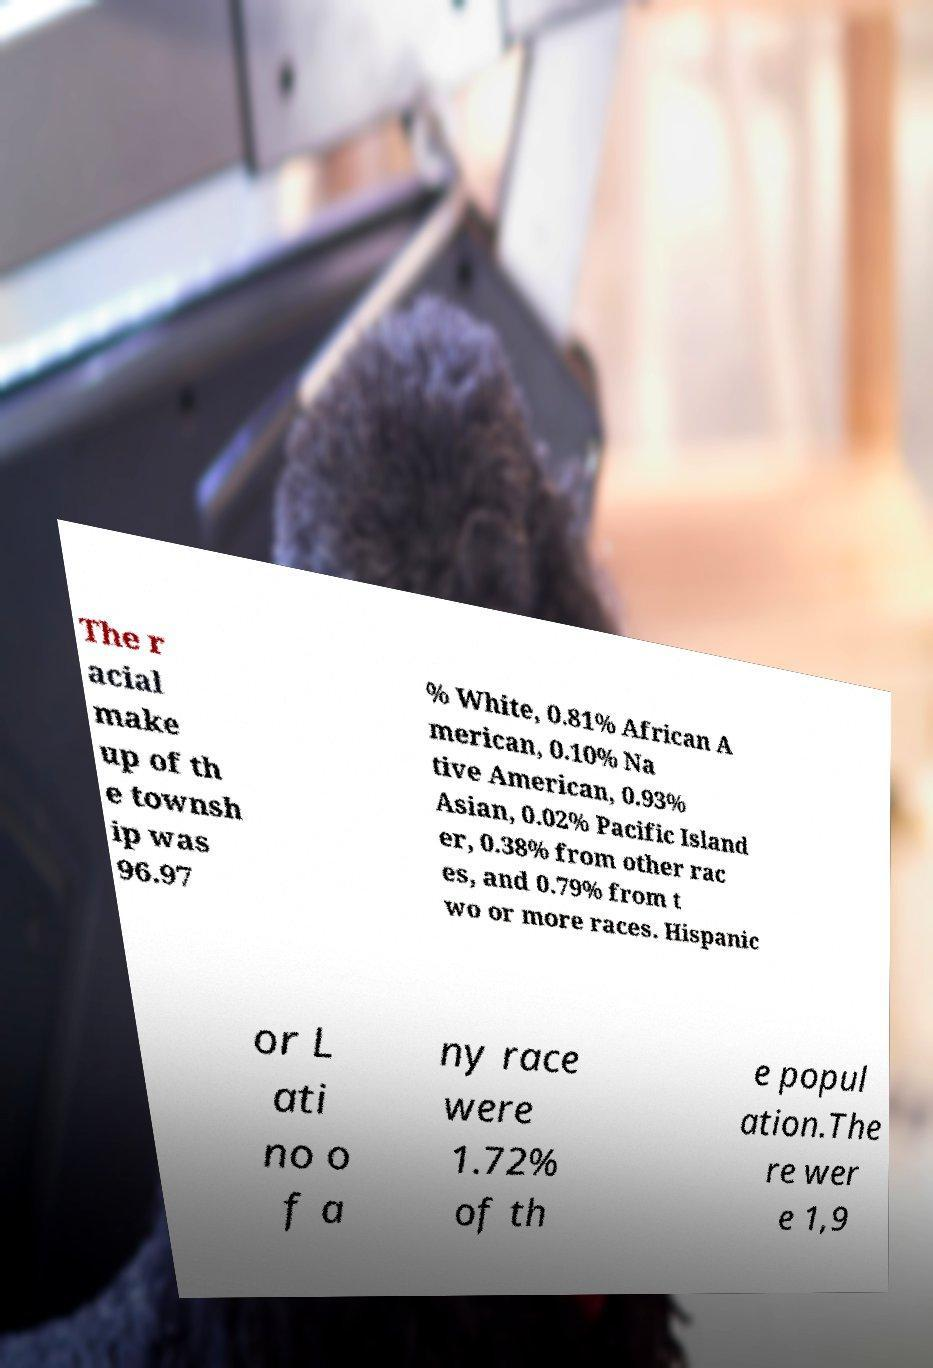I need the written content from this picture converted into text. Can you do that? The r acial make up of th e townsh ip was 96.97 % White, 0.81% African A merican, 0.10% Na tive American, 0.93% Asian, 0.02% Pacific Island er, 0.38% from other rac es, and 0.79% from t wo or more races. Hispanic or L ati no o f a ny race were 1.72% of th e popul ation.The re wer e 1,9 